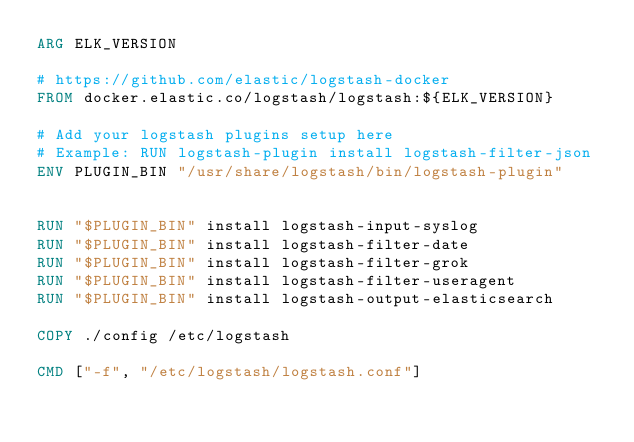Convert code to text. <code><loc_0><loc_0><loc_500><loc_500><_Dockerfile_>ARG ELK_VERSION

# https://github.com/elastic/logstash-docker
FROM docker.elastic.co/logstash/logstash:${ELK_VERSION}

# Add your logstash plugins setup here
# Example: RUN logstash-plugin install logstash-filter-json
ENV PLUGIN_BIN "/usr/share/logstash/bin/logstash-plugin"


RUN "$PLUGIN_BIN" install logstash-input-syslog
RUN "$PLUGIN_BIN" install logstash-filter-date
RUN "$PLUGIN_BIN" install logstash-filter-grok
RUN "$PLUGIN_BIN" install logstash-filter-useragent
RUN "$PLUGIN_BIN" install logstash-output-elasticsearch

COPY ./config /etc/logstash

CMD ["-f", "/etc/logstash/logstash.conf"]</code> 